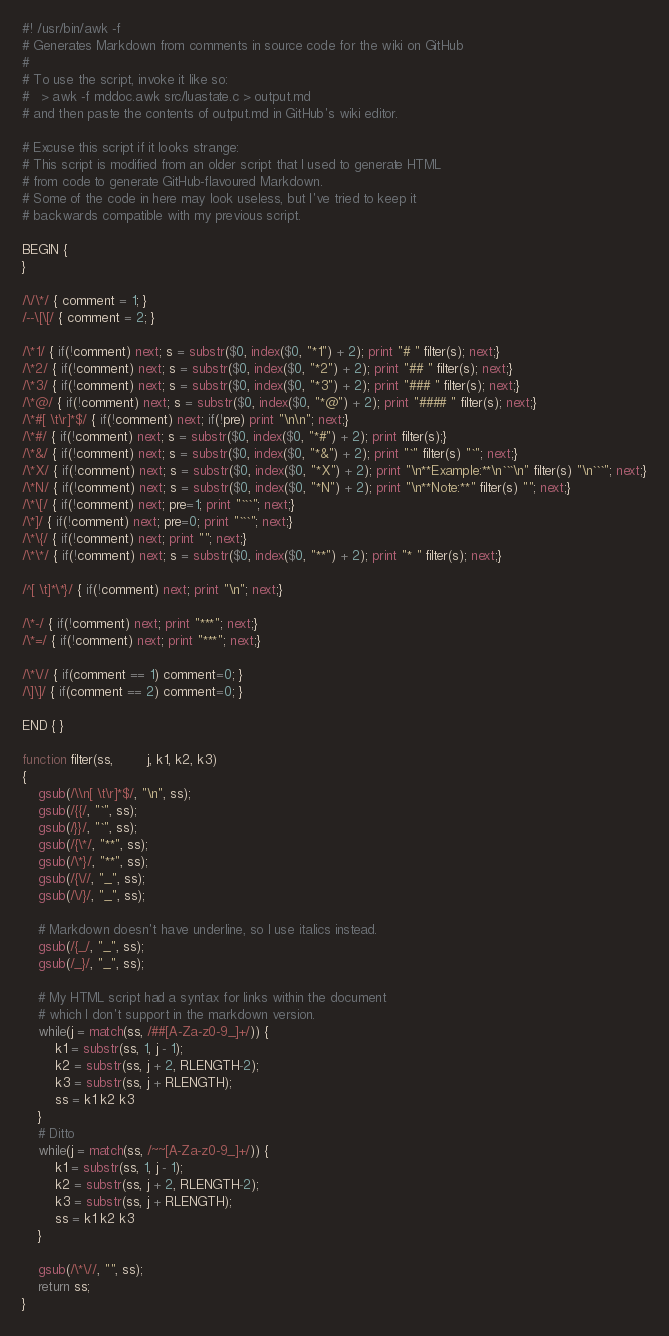<code> <loc_0><loc_0><loc_500><loc_500><_Awk_>#! /usr/bin/awk -f 
# Generates Markdown from comments in source code for the wiki on GitHub
#
# To use the script, invoke it like so:
#   > awk -f mddoc.awk src/luastate.c > output.md
# and then paste the contents of output.md in GitHub's wiki editor.

# Excuse this script if it looks strange:
# This script is modified from an older script that I used to generate HTML 
# from code to generate GitHub-flavoured Markdown.
# Some of the code in here may look useless, but I've tried to keep it 
# backwards compatible with my previous script.

BEGIN { 
}

/\/\*/ { comment = 1; }
/--\[\[/ { comment = 2; }

/\*1/ { if(!comment) next; s = substr($0, index($0, "*1") + 2); print "# " filter(s); next;}
/\*2/ { if(!comment) next; s = substr($0, index($0, "*2") + 2); print "## " filter(s); next;}
/\*3/ { if(!comment) next; s = substr($0, index($0, "*3") + 2); print "### " filter(s); next;}
/\*@/ { if(!comment) next; s = substr($0, index($0, "*@") + 2); print "#### " filter(s); next;}
/\*#[ \t\r]*$/ { if(!comment) next; if(!pre) print "\n\n"; next;}
/\*#/ { if(!comment) next; s = substr($0, index($0, "*#") + 2); print filter(s);}
/\*&/ { if(!comment) next; s = substr($0, index($0, "*&") + 2); print "`" filter(s) "`"; next;}
/\*X/ { if(!comment) next; s = substr($0, index($0, "*X") + 2); print "\n**Example:**\n```\n" filter(s) "\n```"; next;}
/\*N/ { if(!comment) next; s = substr($0, index($0, "*N") + 2); print "\n**Note:**" filter(s) ""; next;}
/\*\[/ { if(!comment) next; pre=1; print "```"; next;}
/\*]/ { if(!comment) next; pre=0; print "```"; next;}
/\*\{/ { if(!comment) next; print ""; next;}
/\*\*/ { if(!comment) next; s = substr($0, index($0, "**") + 2); print "* " filter(s); next;}

/^[ \t]*\*}/ { if(!comment) next; print "\n"; next;}

/\*-/ { if(!comment) next; print "***"; next;}
/\*=/ { if(!comment) next; print "***"; next;}

/\*\// { if(comment == 1) comment=0; }
/\]\]/ { if(comment == 2) comment=0; }

END { }

function filter(ss,        j, k1, k2, k3)
{
	gsub(/\\n[ \t\r]*$/, "\n", ss);
	gsub(/{{/, "`", ss); 
	gsub(/}}/, "`", ss);
	gsub(/{\*/, "**", ss); 
	gsub(/\*}/, "**", ss);
	gsub(/{\//, "_", ss); 
	gsub(/\/}/, "_", ss);
	
	# Markdown doesn't have underline, so I use italics instead.
	gsub(/{_/, "_", ss); 
	gsub(/_}/, "_", ss);	
		
	# My HTML script had a syntax for links within the document
	# which I don't support in the markdown version.
	while(j = match(ss, /##[A-Za-z0-9_]+/)) {
		k1 = substr(ss, 1, j - 1);
		k2 = substr(ss, j + 2, RLENGTH-2);
		k3 = substr(ss, j + RLENGTH);
		ss = k1 k2 k3
	}	
	# Ditto
	while(j = match(ss, /~~[A-Za-z0-9_]+/)) {
		k1 = substr(ss, 1, j - 1);
		k2 = substr(ss, j + 2, RLENGTH-2);
		k3 = substr(ss, j + RLENGTH);
		ss = k1 k2 k3
	}
	
	gsub(/\*\//, "", ss);
	return ss;
}
</code> 